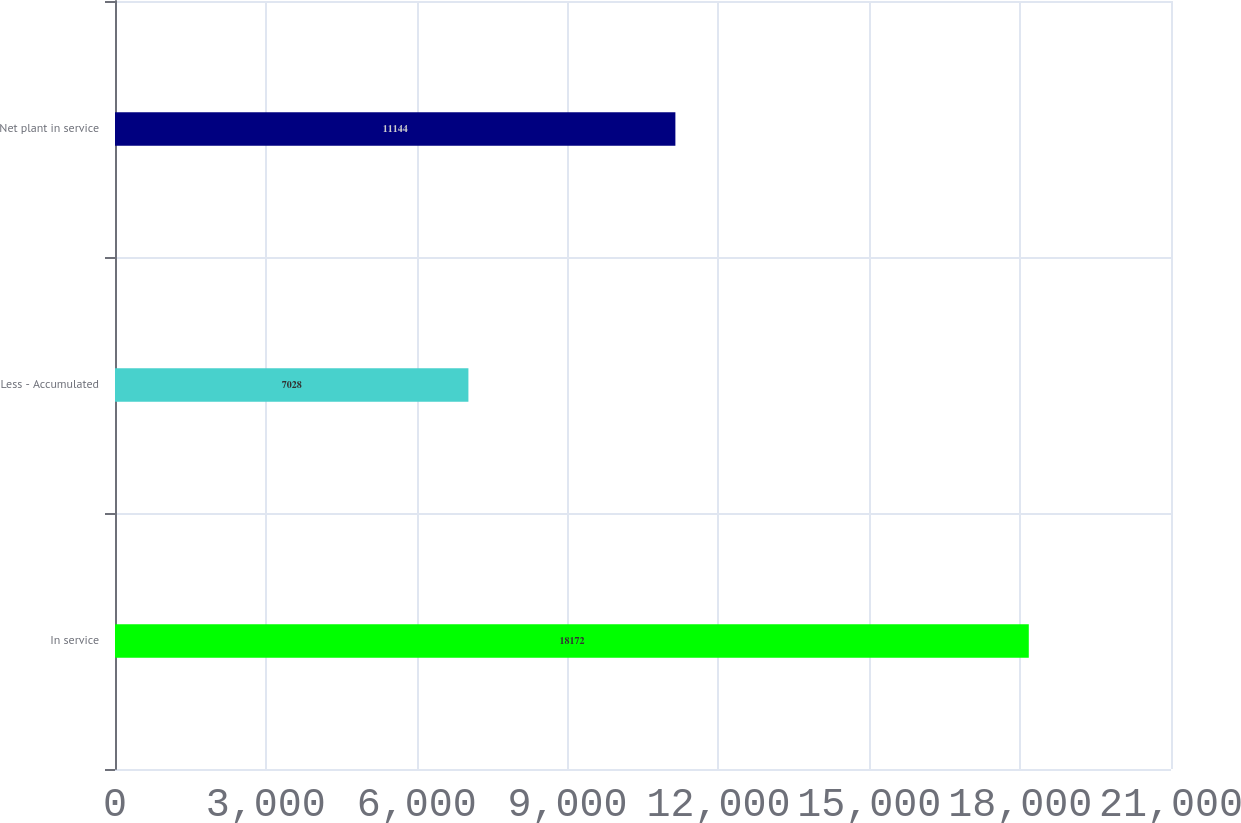Convert chart to OTSL. <chart><loc_0><loc_0><loc_500><loc_500><bar_chart><fcel>In service<fcel>Less - Accumulated<fcel>Net plant in service<nl><fcel>18172<fcel>7028<fcel>11144<nl></chart> 